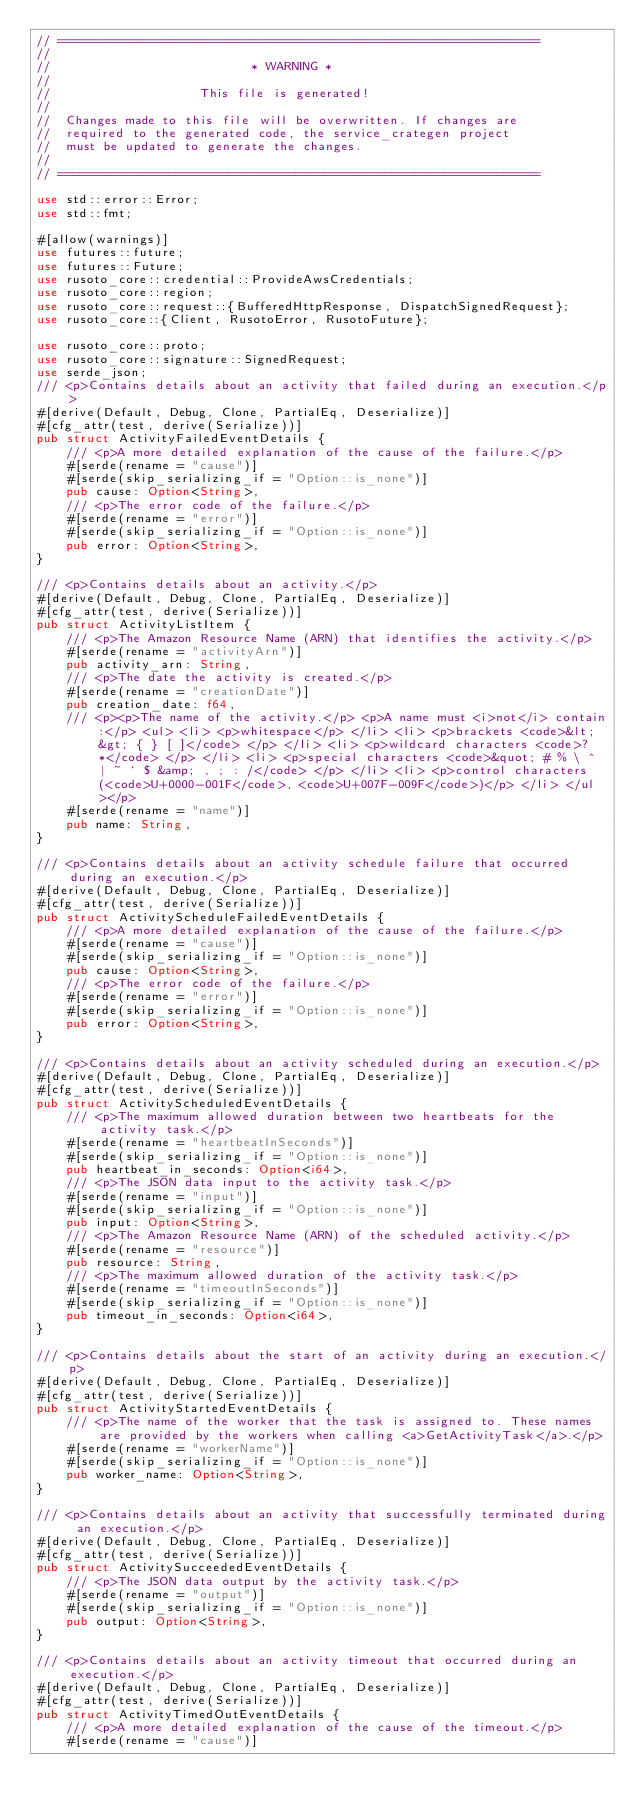<code> <loc_0><loc_0><loc_500><loc_500><_Rust_>// =================================================================
//
//                           * WARNING *
//
//                    This file is generated!
//
//  Changes made to this file will be overwritten. If changes are
//  required to the generated code, the service_crategen project
//  must be updated to generate the changes.
//
// =================================================================

use std::error::Error;
use std::fmt;

#[allow(warnings)]
use futures::future;
use futures::Future;
use rusoto_core::credential::ProvideAwsCredentials;
use rusoto_core::region;
use rusoto_core::request::{BufferedHttpResponse, DispatchSignedRequest};
use rusoto_core::{Client, RusotoError, RusotoFuture};

use rusoto_core::proto;
use rusoto_core::signature::SignedRequest;
use serde_json;
/// <p>Contains details about an activity that failed during an execution.</p>
#[derive(Default, Debug, Clone, PartialEq, Deserialize)]
#[cfg_attr(test, derive(Serialize))]
pub struct ActivityFailedEventDetails {
    /// <p>A more detailed explanation of the cause of the failure.</p>
    #[serde(rename = "cause")]
    #[serde(skip_serializing_if = "Option::is_none")]
    pub cause: Option<String>,
    /// <p>The error code of the failure.</p>
    #[serde(rename = "error")]
    #[serde(skip_serializing_if = "Option::is_none")]
    pub error: Option<String>,
}

/// <p>Contains details about an activity.</p>
#[derive(Default, Debug, Clone, PartialEq, Deserialize)]
#[cfg_attr(test, derive(Serialize))]
pub struct ActivityListItem {
    /// <p>The Amazon Resource Name (ARN) that identifies the activity.</p>
    #[serde(rename = "activityArn")]
    pub activity_arn: String,
    /// <p>The date the activity is created.</p>
    #[serde(rename = "creationDate")]
    pub creation_date: f64,
    /// <p><p>The name of the activity.</p> <p>A name must <i>not</i> contain:</p> <ul> <li> <p>whitespace</p> </li> <li> <p>brackets <code>&lt; &gt; { } [ ]</code> </p> </li> <li> <p>wildcard characters <code>? *</code> </p> </li> <li> <p>special characters <code>&quot; # % \ ^ | ~ ` $ &amp; , ; : /</code> </p> </li> <li> <p>control characters (<code>U+0000-001F</code>, <code>U+007F-009F</code>)</p> </li> </ul></p>
    #[serde(rename = "name")]
    pub name: String,
}

/// <p>Contains details about an activity schedule failure that occurred during an execution.</p>
#[derive(Default, Debug, Clone, PartialEq, Deserialize)]
#[cfg_attr(test, derive(Serialize))]
pub struct ActivityScheduleFailedEventDetails {
    /// <p>A more detailed explanation of the cause of the failure.</p>
    #[serde(rename = "cause")]
    #[serde(skip_serializing_if = "Option::is_none")]
    pub cause: Option<String>,
    /// <p>The error code of the failure.</p>
    #[serde(rename = "error")]
    #[serde(skip_serializing_if = "Option::is_none")]
    pub error: Option<String>,
}

/// <p>Contains details about an activity scheduled during an execution.</p>
#[derive(Default, Debug, Clone, PartialEq, Deserialize)]
#[cfg_attr(test, derive(Serialize))]
pub struct ActivityScheduledEventDetails {
    /// <p>The maximum allowed duration between two heartbeats for the activity task.</p>
    #[serde(rename = "heartbeatInSeconds")]
    #[serde(skip_serializing_if = "Option::is_none")]
    pub heartbeat_in_seconds: Option<i64>,
    /// <p>The JSON data input to the activity task.</p>
    #[serde(rename = "input")]
    #[serde(skip_serializing_if = "Option::is_none")]
    pub input: Option<String>,
    /// <p>The Amazon Resource Name (ARN) of the scheduled activity.</p>
    #[serde(rename = "resource")]
    pub resource: String,
    /// <p>The maximum allowed duration of the activity task.</p>
    #[serde(rename = "timeoutInSeconds")]
    #[serde(skip_serializing_if = "Option::is_none")]
    pub timeout_in_seconds: Option<i64>,
}

/// <p>Contains details about the start of an activity during an execution.</p>
#[derive(Default, Debug, Clone, PartialEq, Deserialize)]
#[cfg_attr(test, derive(Serialize))]
pub struct ActivityStartedEventDetails {
    /// <p>The name of the worker that the task is assigned to. These names are provided by the workers when calling <a>GetActivityTask</a>.</p>
    #[serde(rename = "workerName")]
    #[serde(skip_serializing_if = "Option::is_none")]
    pub worker_name: Option<String>,
}

/// <p>Contains details about an activity that successfully terminated during an execution.</p>
#[derive(Default, Debug, Clone, PartialEq, Deserialize)]
#[cfg_attr(test, derive(Serialize))]
pub struct ActivitySucceededEventDetails {
    /// <p>The JSON data output by the activity task.</p>
    #[serde(rename = "output")]
    #[serde(skip_serializing_if = "Option::is_none")]
    pub output: Option<String>,
}

/// <p>Contains details about an activity timeout that occurred during an execution.</p>
#[derive(Default, Debug, Clone, PartialEq, Deserialize)]
#[cfg_attr(test, derive(Serialize))]
pub struct ActivityTimedOutEventDetails {
    /// <p>A more detailed explanation of the cause of the timeout.</p>
    #[serde(rename = "cause")]</code> 